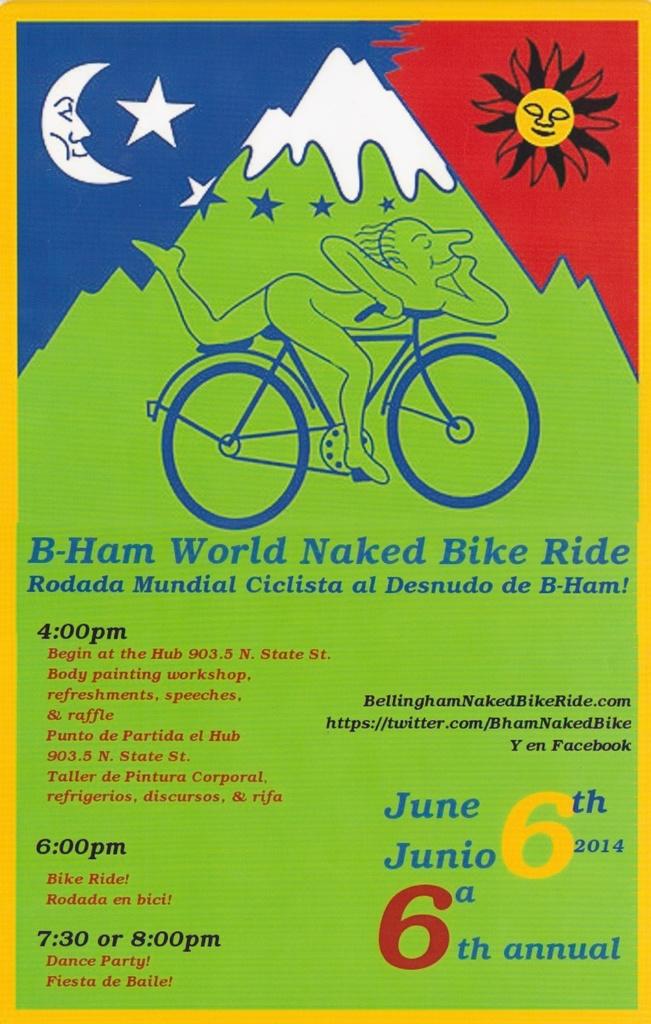What time does the bike ride start?
Your answer should be very brief. 6:00 pm. What date does this event take place?
Provide a succinct answer. June 6th. 